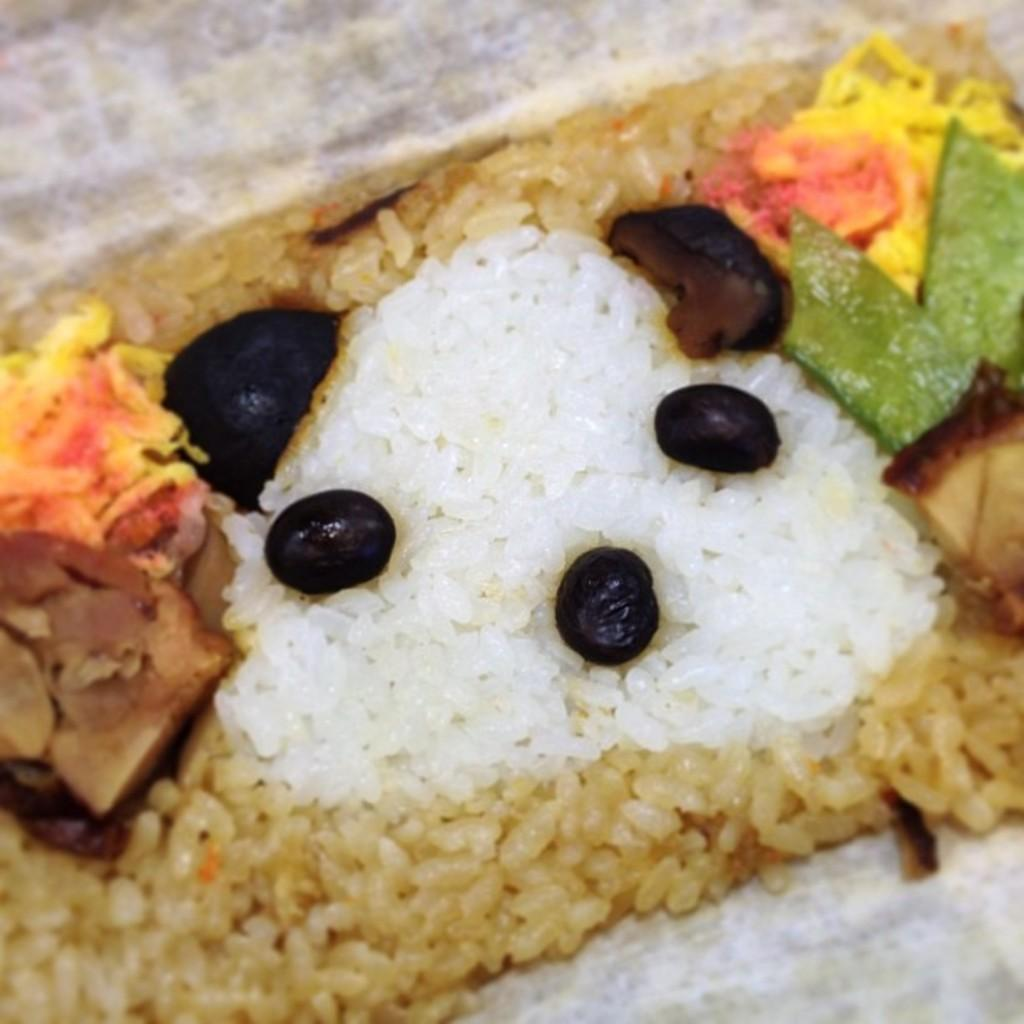What type of food can be seen in the image? There are fruits, rice, and other food items on a plate in the image. Can you describe the color combination of the background in the image? The background of the image has a gray and white color combination. How many deer can be seen grazing on the edge of the plate in the image? There are no deer present in the image; it features food items on a plate. What type of food is the deer eating in the image? There is no deer present in the image, so it cannot be determined what type of food it might be eating. 